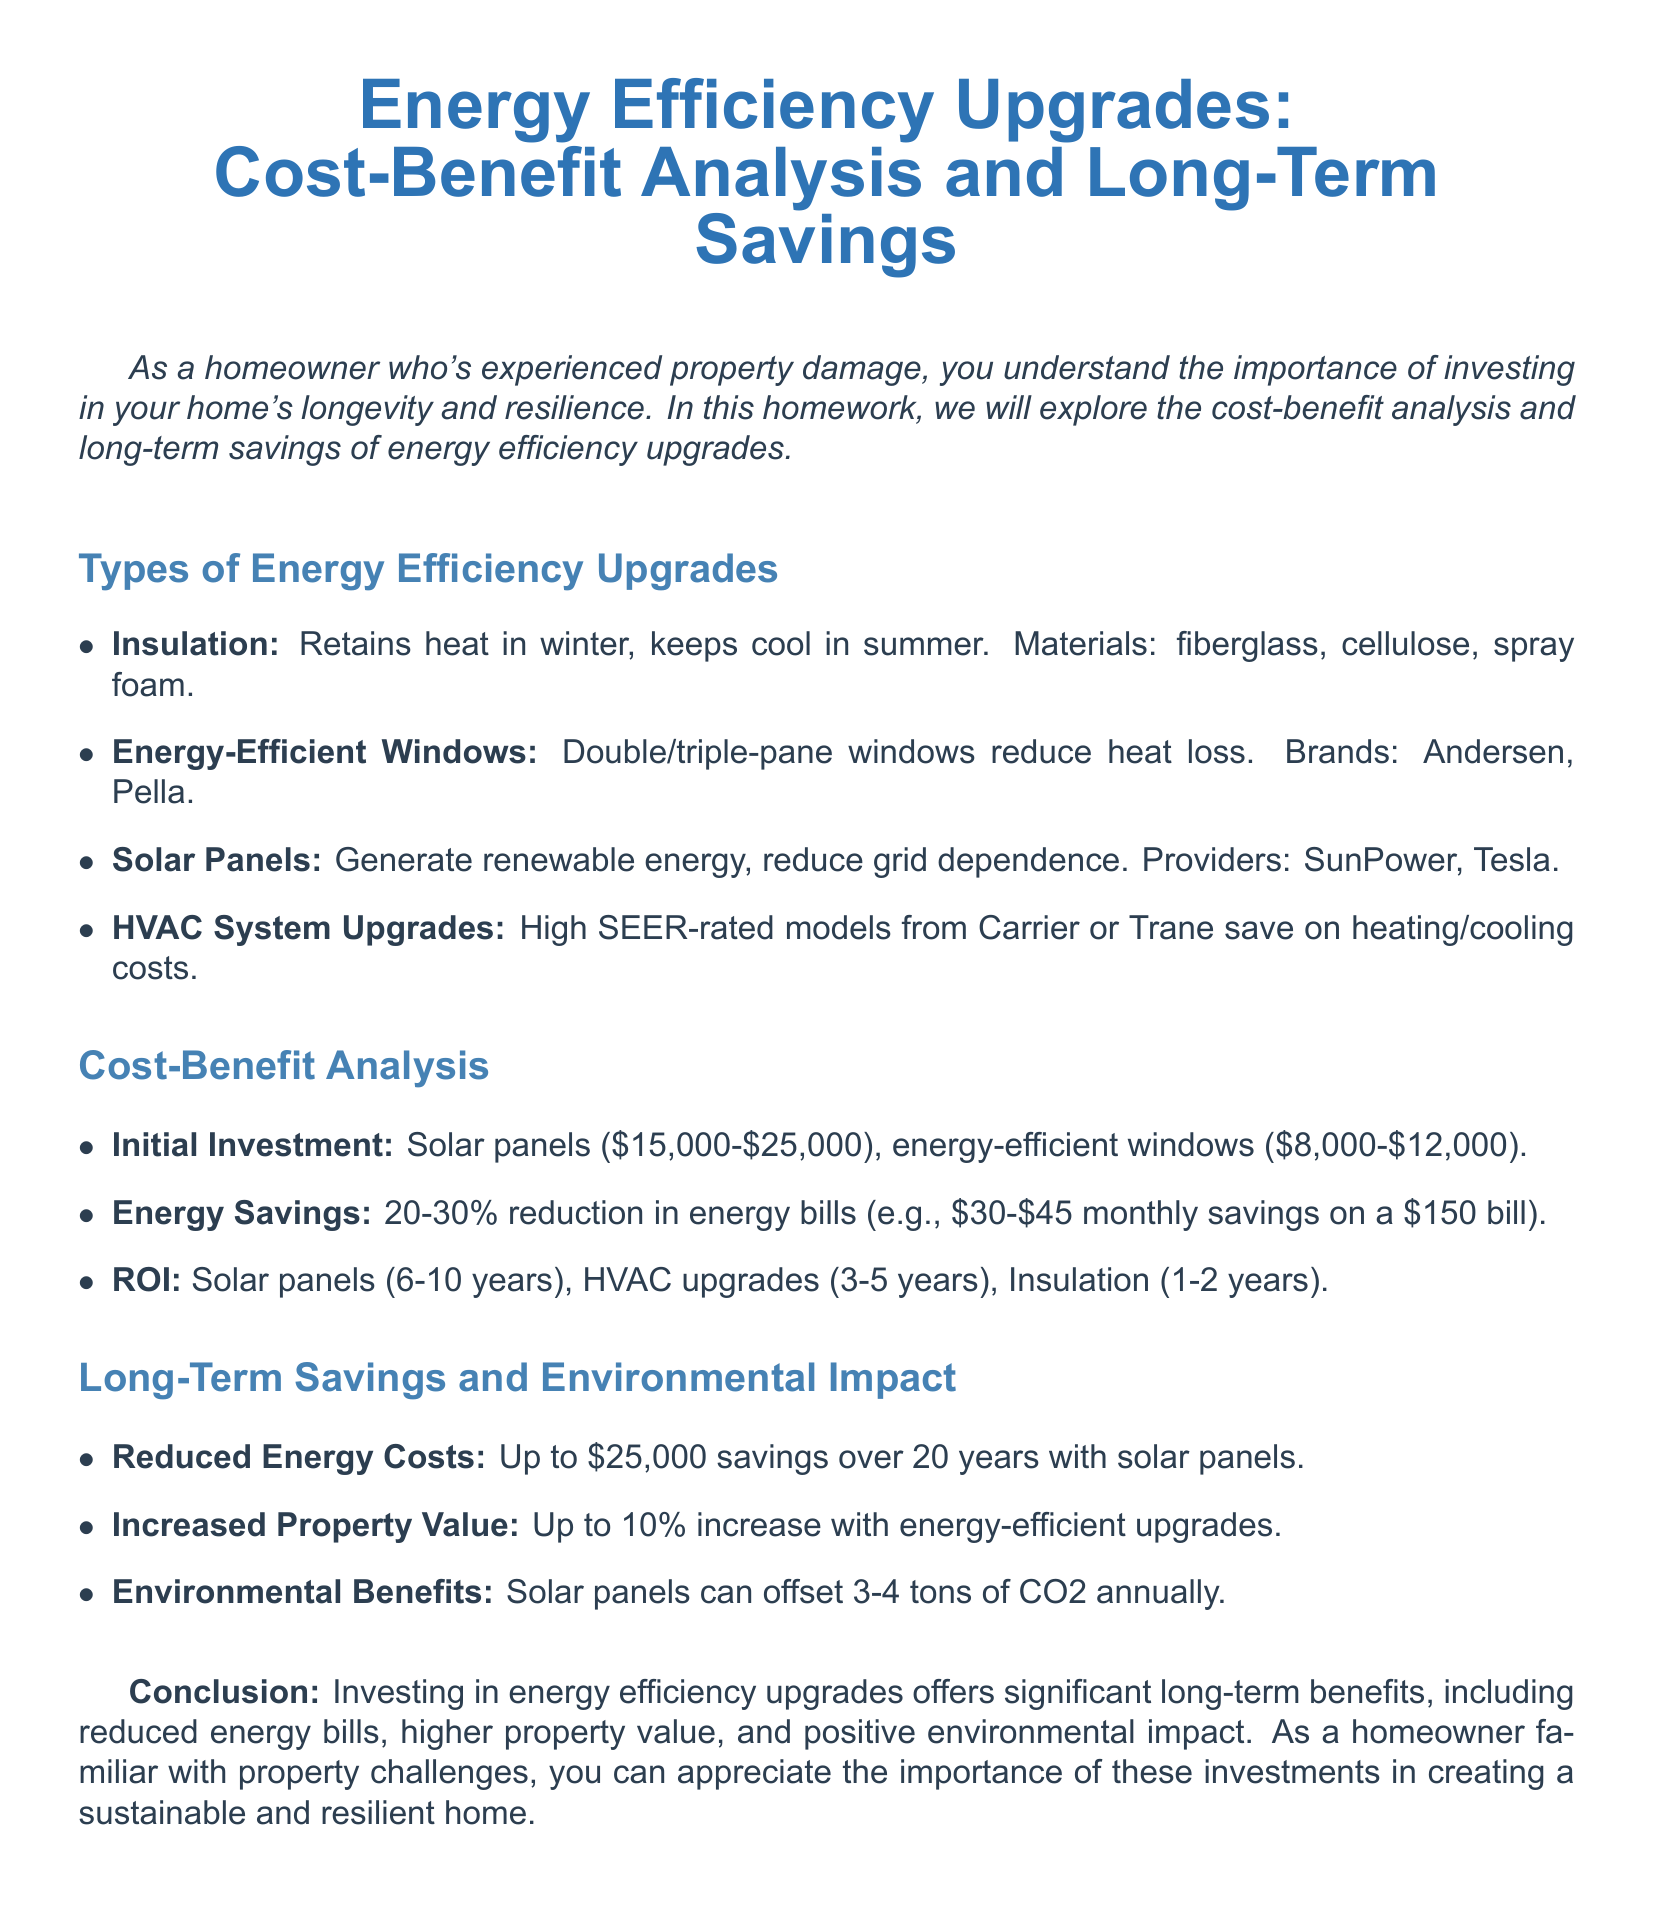What is one type of energy efficiency upgrade? The document lists various energy efficiency upgrades such as insulation, energy-efficient windows, solar panels, and HVAC system upgrades.
Answer: Insulation What is the cost range for solar panels? The document specifies the initial investment cost for solar panels, which is between $15,000 and $25,000.
Answer: $15,000-$25,000 What percentage reduction in energy bills does the document suggest? The document states that energy efficiency upgrades can lead to a 20-30% reduction in energy bills.
Answer: 20-30% What is the ROI period for HVAC system upgrades? The document indicates that the ROI for HVAC upgrades is estimated to be between 3 to 5 years.
Answer: 3-5 years How much can solar panels save a homeowner over 20 years? According to the document, solar panels can help save up to $25,000 over a 20-year period.
Answer: $25,000 What environmental benefit is stated regarding solar panels? The document mentions that solar panels can offset 3-4 tons of CO2 annually.
Answer: 3-4 tons of CO2 What is the potential increase in property value from energy-efficient upgrades? The document indicates that energy-efficient upgrades can increase property value by up to 10%.
Answer: 10% Which brands are mentioned for energy-efficient windows? The document lists Andersen and Pella as brands for energy-efficient windows.
Answer: Andersen, Pella 